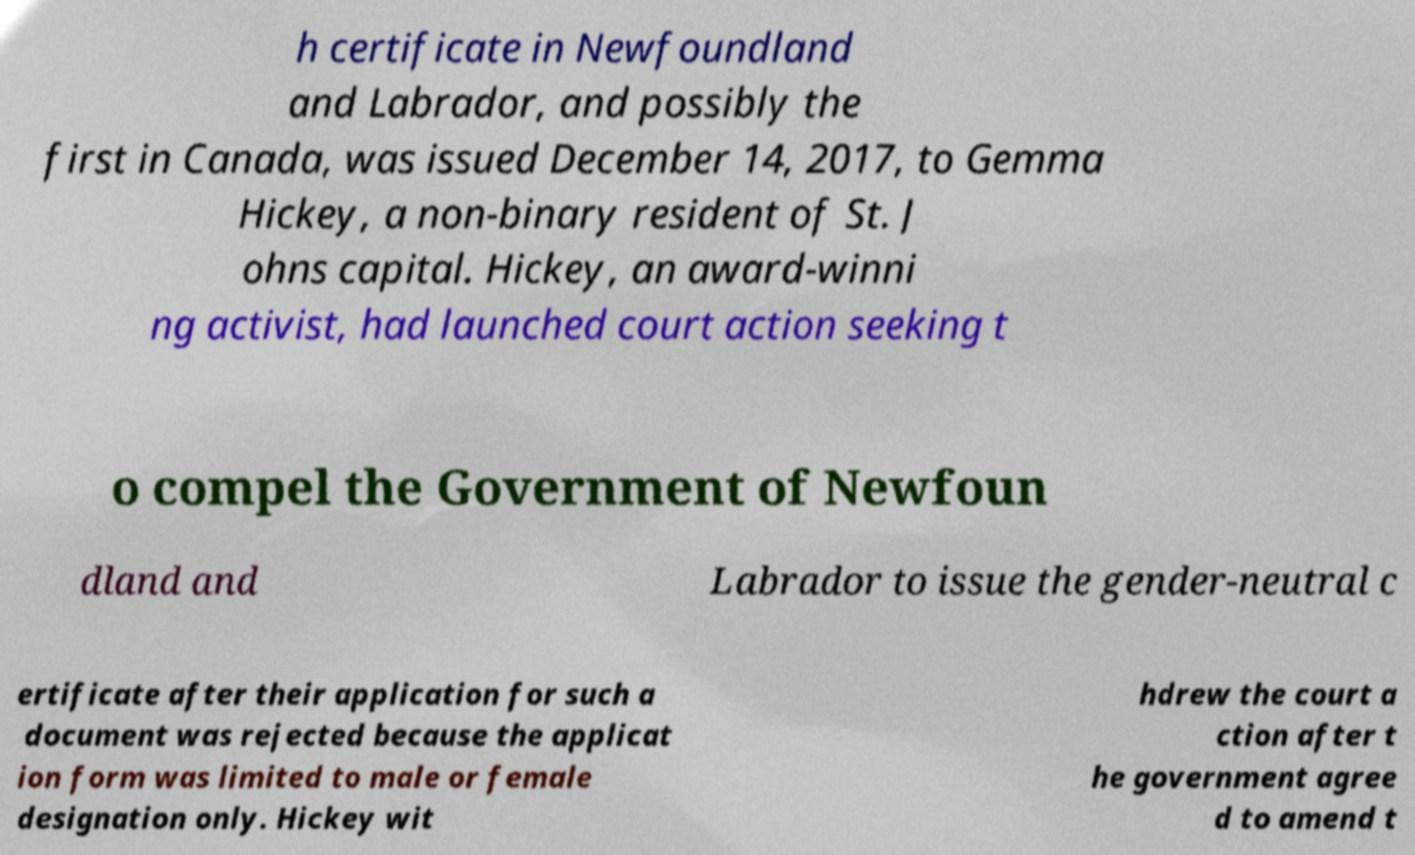There's text embedded in this image that I need extracted. Can you transcribe it verbatim? h certificate in Newfoundland and Labrador, and possibly the first in Canada, was issued December 14, 2017, to Gemma Hickey, a non-binary resident of St. J ohns capital. Hickey, an award-winni ng activist, had launched court action seeking t o compel the Government of Newfoun dland and Labrador to issue the gender-neutral c ertificate after their application for such a document was rejected because the applicat ion form was limited to male or female designation only. Hickey wit hdrew the court a ction after t he government agree d to amend t 